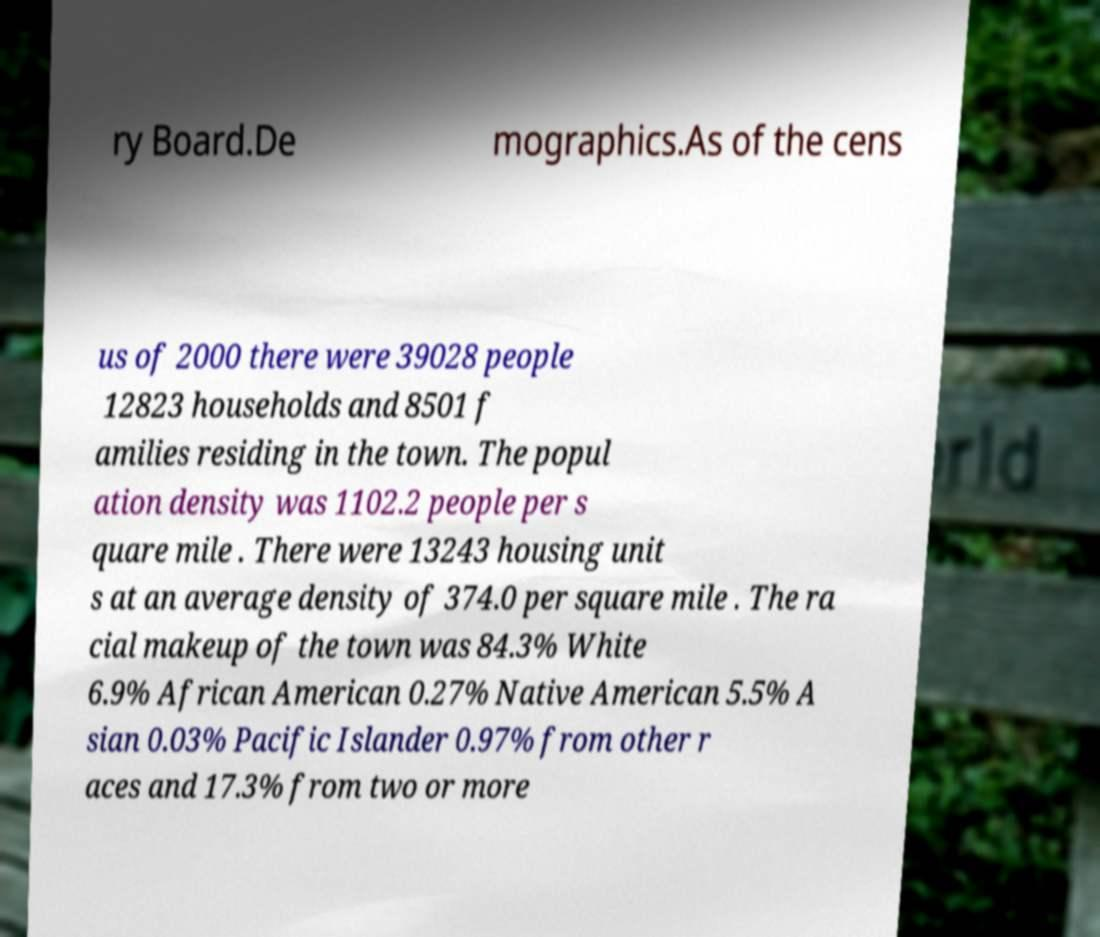Could you assist in decoding the text presented in this image and type it out clearly? ry Board.De mographics.As of the cens us of 2000 there were 39028 people 12823 households and 8501 f amilies residing in the town. The popul ation density was 1102.2 people per s quare mile . There were 13243 housing unit s at an average density of 374.0 per square mile . The ra cial makeup of the town was 84.3% White 6.9% African American 0.27% Native American 5.5% A sian 0.03% Pacific Islander 0.97% from other r aces and 17.3% from two or more 